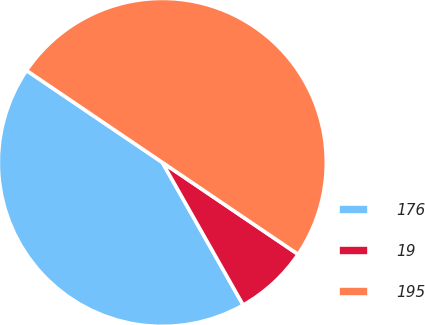<chart> <loc_0><loc_0><loc_500><loc_500><pie_chart><fcel>176<fcel>19<fcel>195<nl><fcel>42.68%<fcel>7.32%<fcel>50.0%<nl></chart> 